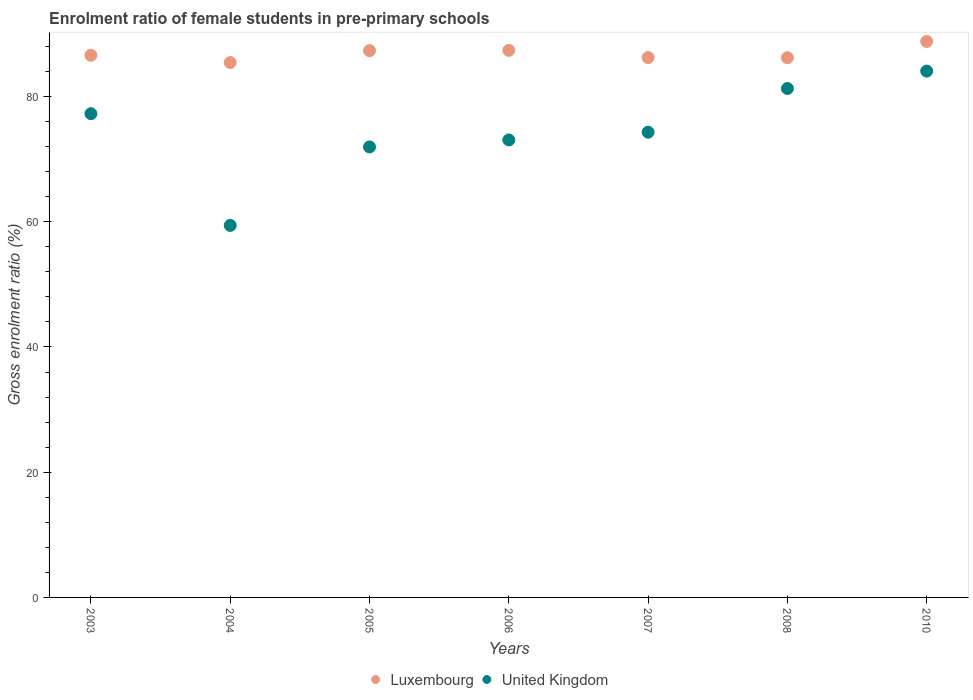What is the enrolment ratio of female students in pre-primary schools in Luxembourg in 2003?
Keep it short and to the point. 86.58. Across all years, what is the maximum enrolment ratio of female students in pre-primary schools in United Kingdom?
Offer a terse response. 84.06. Across all years, what is the minimum enrolment ratio of female students in pre-primary schools in United Kingdom?
Make the answer very short. 59.41. In which year was the enrolment ratio of female students in pre-primary schools in Luxembourg maximum?
Give a very brief answer. 2010. What is the total enrolment ratio of female students in pre-primary schools in Luxembourg in the graph?
Provide a succinct answer. 607.91. What is the difference between the enrolment ratio of female students in pre-primary schools in United Kingdom in 2004 and that in 2010?
Offer a terse response. -24.65. What is the difference between the enrolment ratio of female students in pre-primary schools in United Kingdom in 2004 and the enrolment ratio of female students in pre-primary schools in Luxembourg in 2003?
Offer a very short reply. -27.17. What is the average enrolment ratio of female students in pre-primary schools in United Kingdom per year?
Your answer should be very brief. 74.47. In the year 2008, what is the difference between the enrolment ratio of female students in pre-primary schools in Luxembourg and enrolment ratio of female students in pre-primary schools in United Kingdom?
Keep it short and to the point. 4.92. What is the ratio of the enrolment ratio of female students in pre-primary schools in United Kingdom in 2003 to that in 2007?
Keep it short and to the point. 1.04. What is the difference between the highest and the second highest enrolment ratio of female students in pre-primary schools in Luxembourg?
Provide a short and direct response. 1.42. What is the difference between the highest and the lowest enrolment ratio of female students in pre-primary schools in Luxembourg?
Make the answer very short. 3.37. Is the sum of the enrolment ratio of female students in pre-primary schools in Luxembourg in 2007 and 2010 greater than the maximum enrolment ratio of female students in pre-primary schools in United Kingdom across all years?
Ensure brevity in your answer.  Yes. Does the graph contain any zero values?
Your answer should be very brief. No. Does the graph contain grids?
Provide a short and direct response. No. How many legend labels are there?
Offer a terse response. 2. How are the legend labels stacked?
Provide a succinct answer. Horizontal. What is the title of the graph?
Provide a short and direct response. Enrolment ratio of female students in pre-primary schools. Does "Sao Tome and Principe" appear as one of the legend labels in the graph?
Your answer should be compact. No. What is the label or title of the X-axis?
Provide a succinct answer. Years. What is the label or title of the Y-axis?
Keep it short and to the point. Gross enrolment ratio (%). What is the Gross enrolment ratio (%) in Luxembourg in 2003?
Give a very brief answer. 86.58. What is the Gross enrolment ratio (%) in United Kingdom in 2003?
Provide a succinct answer. 77.26. What is the Gross enrolment ratio (%) of Luxembourg in 2004?
Keep it short and to the point. 85.42. What is the Gross enrolment ratio (%) in United Kingdom in 2004?
Provide a succinct answer. 59.41. What is the Gross enrolment ratio (%) of Luxembourg in 2005?
Your answer should be compact. 87.32. What is the Gross enrolment ratio (%) in United Kingdom in 2005?
Keep it short and to the point. 71.95. What is the Gross enrolment ratio (%) in Luxembourg in 2006?
Your response must be concise. 87.37. What is the Gross enrolment ratio (%) of United Kingdom in 2006?
Your answer should be compact. 73.06. What is the Gross enrolment ratio (%) in Luxembourg in 2007?
Offer a terse response. 86.22. What is the Gross enrolment ratio (%) of United Kingdom in 2007?
Your answer should be compact. 74.3. What is the Gross enrolment ratio (%) in Luxembourg in 2008?
Ensure brevity in your answer.  86.2. What is the Gross enrolment ratio (%) of United Kingdom in 2008?
Keep it short and to the point. 81.28. What is the Gross enrolment ratio (%) of Luxembourg in 2010?
Provide a succinct answer. 88.79. What is the Gross enrolment ratio (%) of United Kingdom in 2010?
Ensure brevity in your answer.  84.06. Across all years, what is the maximum Gross enrolment ratio (%) in Luxembourg?
Make the answer very short. 88.79. Across all years, what is the maximum Gross enrolment ratio (%) in United Kingdom?
Give a very brief answer. 84.06. Across all years, what is the minimum Gross enrolment ratio (%) in Luxembourg?
Your response must be concise. 85.42. Across all years, what is the minimum Gross enrolment ratio (%) of United Kingdom?
Offer a terse response. 59.41. What is the total Gross enrolment ratio (%) of Luxembourg in the graph?
Your answer should be compact. 607.91. What is the total Gross enrolment ratio (%) of United Kingdom in the graph?
Give a very brief answer. 521.31. What is the difference between the Gross enrolment ratio (%) in Luxembourg in 2003 and that in 2004?
Provide a succinct answer. 1.16. What is the difference between the Gross enrolment ratio (%) of United Kingdom in 2003 and that in 2004?
Your response must be concise. 17.85. What is the difference between the Gross enrolment ratio (%) in Luxembourg in 2003 and that in 2005?
Your answer should be very brief. -0.74. What is the difference between the Gross enrolment ratio (%) of United Kingdom in 2003 and that in 2005?
Your answer should be very brief. 5.31. What is the difference between the Gross enrolment ratio (%) of Luxembourg in 2003 and that in 2006?
Make the answer very short. -0.79. What is the difference between the Gross enrolment ratio (%) in United Kingdom in 2003 and that in 2006?
Your answer should be compact. 4.19. What is the difference between the Gross enrolment ratio (%) in Luxembourg in 2003 and that in 2007?
Offer a very short reply. 0.36. What is the difference between the Gross enrolment ratio (%) of United Kingdom in 2003 and that in 2007?
Give a very brief answer. 2.96. What is the difference between the Gross enrolment ratio (%) in Luxembourg in 2003 and that in 2008?
Provide a succinct answer. 0.39. What is the difference between the Gross enrolment ratio (%) in United Kingdom in 2003 and that in 2008?
Offer a very short reply. -4.02. What is the difference between the Gross enrolment ratio (%) in Luxembourg in 2003 and that in 2010?
Ensure brevity in your answer.  -2.21. What is the difference between the Gross enrolment ratio (%) in United Kingdom in 2003 and that in 2010?
Provide a short and direct response. -6.8. What is the difference between the Gross enrolment ratio (%) of Luxembourg in 2004 and that in 2005?
Keep it short and to the point. -1.9. What is the difference between the Gross enrolment ratio (%) of United Kingdom in 2004 and that in 2005?
Provide a short and direct response. -12.54. What is the difference between the Gross enrolment ratio (%) of Luxembourg in 2004 and that in 2006?
Make the answer very short. -1.95. What is the difference between the Gross enrolment ratio (%) in United Kingdom in 2004 and that in 2006?
Your answer should be compact. -13.65. What is the difference between the Gross enrolment ratio (%) in Luxembourg in 2004 and that in 2007?
Provide a short and direct response. -0.8. What is the difference between the Gross enrolment ratio (%) of United Kingdom in 2004 and that in 2007?
Give a very brief answer. -14.89. What is the difference between the Gross enrolment ratio (%) in Luxembourg in 2004 and that in 2008?
Provide a short and direct response. -0.77. What is the difference between the Gross enrolment ratio (%) in United Kingdom in 2004 and that in 2008?
Your response must be concise. -21.87. What is the difference between the Gross enrolment ratio (%) in Luxembourg in 2004 and that in 2010?
Your response must be concise. -3.37. What is the difference between the Gross enrolment ratio (%) of United Kingdom in 2004 and that in 2010?
Give a very brief answer. -24.65. What is the difference between the Gross enrolment ratio (%) of Luxembourg in 2005 and that in 2006?
Your response must be concise. -0.05. What is the difference between the Gross enrolment ratio (%) in United Kingdom in 2005 and that in 2006?
Your answer should be compact. -1.12. What is the difference between the Gross enrolment ratio (%) of Luxembourg in 2005 and that in 2007?
Keep it short and to the point. 1.1. What is the difference between the Gross enrolment ratio (%) of United Kingdom in 2005 and that in 2007?
Offer a terse response. -2.35. What is the difference between the Gross enrolment ratio (%) of Luxembourg in 2005 and that in 2008?
Ensure brevity in your answer.  1.13. What is the difference between the Gross enrolment ratio (%) of United Kingdom in 2005 and that in 2008?
Your answer should be very brief. -9.33. What is the difference between the Gross enrolment ratio (%) in Luxembourg in 2005 and that in 2010?
Your answer should be very brief. -1.47. What is the difference between the Gross enrolment ratio (%) in United Kingdom in 2005 and that in 2010?
Offer a terse response. -12.11. What is the difference between the Gross enrolment ratio (%) in Luxembourg in 2006 and that in 2007?
Keep it short and to the point. 1.15. What is the difference between the Gross enrolment ratio (%) in United Kingdom in 2006 and that in 2007?
Provide a succinct answer. -1.24. What is the difference between the Gross enrolment ratio (%) in Luxembourg in 2006 and that in 2008?
Your answer should be very brief. 1.17. What is the difference between the Gross enrolment ratio (%) in United Kingdom in 2006 and that in 2008?
Ensure brevity in your answer.  -8.22. What is the difference between the Gross enrolment ratio (%) in Luxembourg in 2006 and that in 2010?
Your response must be concise. -1.42. What is the difference between the Gross enrolment ratio (%) in United Kingdom in 2006 and that in 2010?
Ensure brevity in your answer.  -10.99. What is the difference between the Gross enrolment ratio (%) in Luxembourg in 2007 and that in 2008?
Your response must be concise. 0.03. What is the difference between the Gross enrolment ratio (%) of United Kingdom in 2007 and that in 2008?
Your answer should be very brief. -6.98. What is the difference between the Gross enrolment ratio (%) of Luxembourg in 2007 and that in 2010?
Offer a very short reply. -2.57. What is the difference between the Gross enrolment ratio (%) in United Kingdom in 2007 and that in 2010?
Offer a terse response. -9.76. What is the difference between the Gross enrolment ratio (%) in Luxembourg in 2008 and that in 2010?
Provide a succinct answer. -2.6. What is the difference between the Gross enrolment ratio (%) of United Kingdom in 2008 and that in 2010?
Give a very brief answer. -2.78. What is the difference between the Gross enrolment ratio (%) of Luxembourg in 2003 and the Gross enrolment ratio (%) of United Kingdom in 2004?
Make the answer very short. 27.17. What is the difference between the Gross enrolment ratio (%) of Luxembourg in 2003 and the Gross enrolment ratio (%) of United Kingdom in 2005?
Make the answer very short. 14.64. What is the difference between the Gross enrolment ratio (%) in Luxembourg in 2003 and the Gross enrolment ratio (%) in United Kingdom in 2006?
Ensure brevity in your answer.  13.52. What is the difference between the Gross enrolment ratio (%) in Luxembourg in 2003 and the Gross enrolment ratio (%) in United Kingdom in 2007?
Provide a short and direct response. 12.28. What is the difference between the Gross enrolment ratio (%) in Luxembourg in 2003 and the Gross enrolment ratio (%) in United Kingdom in 2008?
Provide a succinct answer. 5.3. What is the difference between the Gross enrolment ratio (%) in Luxembourg in 2003 and the Gross enrolment ratio (%) in United Kingdom in 2010?
Your answer should be compact. 2.53. What is the difference between the Gross enrolment ratio (%) in Luxembourg in 2004 and the Gross enrolment ratio (%) in United Kingdom in 2005?
Your answer should be very brief. 13.48. What is the difference between the Gross enrolment ratio (%) of Luxembourg in 2004 and the Gross enrolment ratio (%) of United Kingdom in 2006?
Your answer should be compact. 12.36. What is the difference between the Gross enrolment ratio (%) of Luxembourg in 2004 and the Gross enrolment ratio (%) of United Kingdom in 2007?
Your response must be concise. 11.12. What is the difference between the Gross enrolment ratio (%) of Luxembourg in 2004 and the Gross enrolment ratio (%) of United Kingdom in 2008?
Keep it short and to the point. 4.14. What is the difference between the Gross enrolment ratio (%) of Luxembourg in 2004 and the Gross enrolment ratio (%) of United Kingdom in 2010?
Keep it short and to the point. 1.37. What is the difference between the Gross enrolment ratio (%) of Luxembourg in 2005 and the Gross enrolment ratio (%) of United Kingdom in 2006?
Give a very brief answer. 14.26. What is the difference between the Gross enrolment ratio (%) of Luxembourg in 2005 and the Gross enrolment ratio (%) of United Kingdom in 2007?
Give a very brief answer. 13.02. What is the difference between the Gross enrolment ratio (%) of Luxembourg in 2005 and the Gross enrolment ratio (%) of United Kingdom in 2008?
Offer a very short reply. 6.04. What is the difference between the Gross enrolment ratio (%) of Luxembourg in 2005 and the Gross enrolment ratio (%) of United Kingdom in 2010?
Make the answer very short. 3.27. What is the difference between the Gross enrolment ratio (%) in Luxembourg in 2006 and the Gross enrolment ratio (%) in United Kingdom in 2007?
Give a very brief answer. 13.07. What is the difference between the Gross enrolment ratio (%) of Luxembourg in 2006 and the Gross enrolment ratio (%) of United Kingdom in 2008?
Make the answer very short. 6.09. What is the difference between the Gross enrolment ratio (%) in Luxembourg in 2006 and the Gross enrolment ratio (%) in United Kingdom in 2010?
Your response must be concise. 3.31. What is the difference between the Gross enrolment ratio (%) of Luxembourg in 2007 and the Gross enrolment ratio (%) of United Kingdom in 2008?
Offer a very short reply. 4.95. What is the difference between the Gross enrolment ratio (%) in Luxembourg in 2007 and the Gross enrolment ratio (%) in United Kingdom in 2010?
Ensure brevity in your answer.  2.17. What is the difference between the Gross enrolment ratio (%) of Luxembourg in 2008 and the Gross enrolment ratio (%) of United Kingdom in 2010?
Offer a terse response. 2.14. What is the average Gross enrolment ratio (%) in Luxembourg per year?
Provide a succinct answer. 86.84. What is the average Gross enrolment ratio (%) of United Kingdom per year?
Provide a succinct answer. 74.47. In the year 2003, what is the difference between the Gross enrolment ratio (%) of Luxembourg and Gross enrolment ratio (%) of United Kingdom?
Offer a terse response. 9.33. In the year 2004, what is the difference between the Gross enrolment ratio (%) in Luxembourg and Gross enrolment ratio (%) in United Kingdom?
Give a very brief answer. 26.01. In the year 2005, what is the difference between the Gross enrolment ratio (%) of Luxembourg and Gross enrolment ratio (%) of United Kingdom?
Keep it short and to the point. 15.37. In the year 2006, what is the difference between the Gross enrolment ratio (%) in Luxembourg and Gross enrolment ratio (%) in United Kingdom?
Your answer should be very brief. 14.31. In the year 2007, what is the difference between the Gross enrolment ratio (%) in Luxembourg and Gross enrolment ratio (%) in United Kingdom?
Give a very brief answer. 11.93. In the year 2008, what is the difference between the Gross enrolment ratio (%) of Luxembourg and Gross enrolment ratio (%) of United Kingdom?
Give a very brief answer. 4.92. In the year 2010, what is the difference between the Gross enrolment ratio (%) of Luxembourg and Gross enrolment ratio (%) of United Kingdom?
Your response must be concise. 4.74. What is the ratio of the Gross enrolment ratio (%) in Luxembourg in 2003 to that in 2004?
Your answer should be compact. 1.01. What is the ratio of the Gross enrolment ratio (%) of United Kingdom in 2003 to that in 2004?
Provide a short and direct response. 1.3. What is the ratio of the Gross enrolment ratio (%) of United Kingdom in 2003 to that in 2005?
Give a very brief answer. 1.07. What is the ratio of the Gross enrolment ratio (%) of United Kingdom in 2003 to that in 2006?
Keep it short and to the point. 1.06. What is the ratio of the Gross enrolment ratio (%) of United Kingdom in 2003 to that in 2007?
Make the answer very short. 1.04. What is the ratio of the Gross enrolment ratio (%) in United Kingdom in 2003 to that in 2008?
Provide a short and direct response. 0.95. What is the ratio of the Gross enrolment ratio (%) of Luxembourg in 2003 to that in 2010?
Your answer should be very brief. 0.98. What is the ratio of the Gross enrolment ratio (%) of United Kingdom in 2003 to that in 2010?
Ensure brevity in your answer.  0.92. What is the ratio of the Gross enrolment ratio (%) in Luxembourg in 2004 to that in 2005?
Offer a terse response. 0.98. What is the ratio of the Gross enrolment ratio (%) of United Kingdom in 2004 to that in 2005?
Provide a succinct answer. 0.83. What is the ratio of the Gross enrolment ratio (%) in Luxembourg in 2004 to that in 2006?
Ensure brevity in your answer.  0.98. What is the ratio of the Gross enrolment ratio (%) of United Kingdom in 2004 to that in 2006?
Provide a short and direct response. 0.81. What is the ratio of the Gross enrolment ratio (%) in Luxembourg in 2004 to that in 2007?
Give a very brief answer. 0.99. What is the ratio of the Gross enrolment ratio (%) in United Kingdom in 2004 to that in 2007?
Your response must be concise. 0.8. What is the ratio of the Gross enrolment ratio (%) in Luxembourg in 2004 to that in 2008?
Your answer should be compact. 0.99. What is the ratio of the Gross enrolment ratio (%) in United Kingdom in 2004 to that in 2008?
Ensure brevity in your answer.  0.73. What is the ratio of the Gross enrolment ratio (%) of Luxembourg in 2004 to that in 2010?
Provide a succinct answer. 0.96. What is the ratio of the Gross enrolment ratio (%) of United Kingdom in 2004 to that in 2010?
Offer a terse response. 0.71. What is the ratio of the Gross enrolment ratio (%) of United Kingdom in 2005 to that in 2006?
Your answer should be very brief. 0.98. What is the ratio of the Gross enrolment ratio (%) in Luxembourg in 2005 to that in 2007?
Offer a very short reply. 1.01. What is the ratio of the Gross enrolment ratio (%) in United Kingdom in 2005 to that in 2007?
Your answer should be very brief. 0.97. What is the ratio of the Gross enrolment ratio (%) of Luxembourg in 2005 to that in 2008?
Offer a terse response. 1.01. What is the ratio of the Gross enrolment ratio (%) of United Kingdom in 2005 to that in 2008?
Your answer should be very brief. 0.89. What is the ratio of the Gross enrolment ratio (%) of Luxembourg in 2005 to that in 2010?
Ensure brevity in your answer.  0.98. What is the ratio of the Gross enrolment ratio (%) in United Kingdom in 2005 to that in 2010?
Keep it short and to the point. 0.86. What is the ratio of the Gross enrolment ratio (%) in Luxembourg in 2006 to that in 2007?
Your answer should be very brief. 1.01. What is the ratio of the Gross enrolment ratio (%) in United Kingdom in 2006 to that in 2007?
Offer a very short reply. 0.98. What is the ratio of the Gross enrolment ratio (%) of Luxembourg in 2006 to that in 2008?
Give a very brief answer. 1.01. What is the ratio of the Gross enrolment ratio (%) of United Kingdom in 2006 to that in 2008?
Your answer should be very brief. 0.9. What is the ratio of the Gross enrolment ratio (%) in Luxembourg in 2006 to that in 2010?
Provide a short and direct response. 0.98. What is the ratio of the Gross enrolment ratio (%) in United Kingdom in 2006 to that in 2010?
Your answer should be compact. 0.87. What is the ratio of the Gross enrolment ratio (%) of United Kingdom in 2007 to that in 2008?
Give a very brief answer. 0.91. What is the ratio of the Gross enrolment ratio (%) in Luxembourg in 2007 to that in 2010?
Provide a short and direct response. 0.97. What is the ratio of the Gross enrolment ratio (%) in United Kingdom in 2007 to that in 2010?
Your answer should be very brief. 0.88. What is the ratio of the Gross enrolment ratio (%) of Luxembourg in 2008 to that in 2010?
Offer a terse response. 0.97. What is the ratio of the Gross enrolment ratio (%) of United Kingdom in 2008 to that in 2010?
Provide a short and direct response. 0.97. What is the difference between the highest and the second highest Gross enrolment ratio (%) of Luxembourg?
Your answer should be compact. 1.42. What is the difference between the highest and the second highest Gross enrolment ratio (%) of United Kingdom?
Make the answer very short. 2.78. What is the difference between the highest and the lowest Gross enrolment ratio (%) of Luxembourg?
Ensure brevity in your answer.  3.37. What is the difference between the highest and the lowest Gross enrolment ratio (%) in United Kingdom?
Your answer should be very brief. 24.65. 